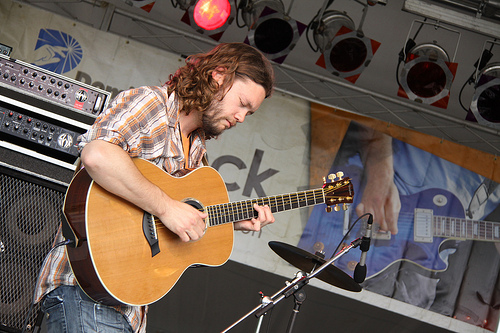<image>
Can you confirm if the guitar is to the left of the man? No. The guitar is not to the left of the man. From this viewpoint, they have a different horizontal relationship. Is the guitar behind the mike? Yes. From this viewpoint, the guitar is positioned behind the mike, with the mike partially or fully occluding the guitar. Is the light behind the speaker? No. The light is not behind the speaker. From this viewpoint, the light appears to be positioned elsewhere in the scene. Where is the music instrument in relation to the man? Is it in front of the man? Yes. The music instrument is positioned in front of the man, appearing closer to the camera viewpoint. 